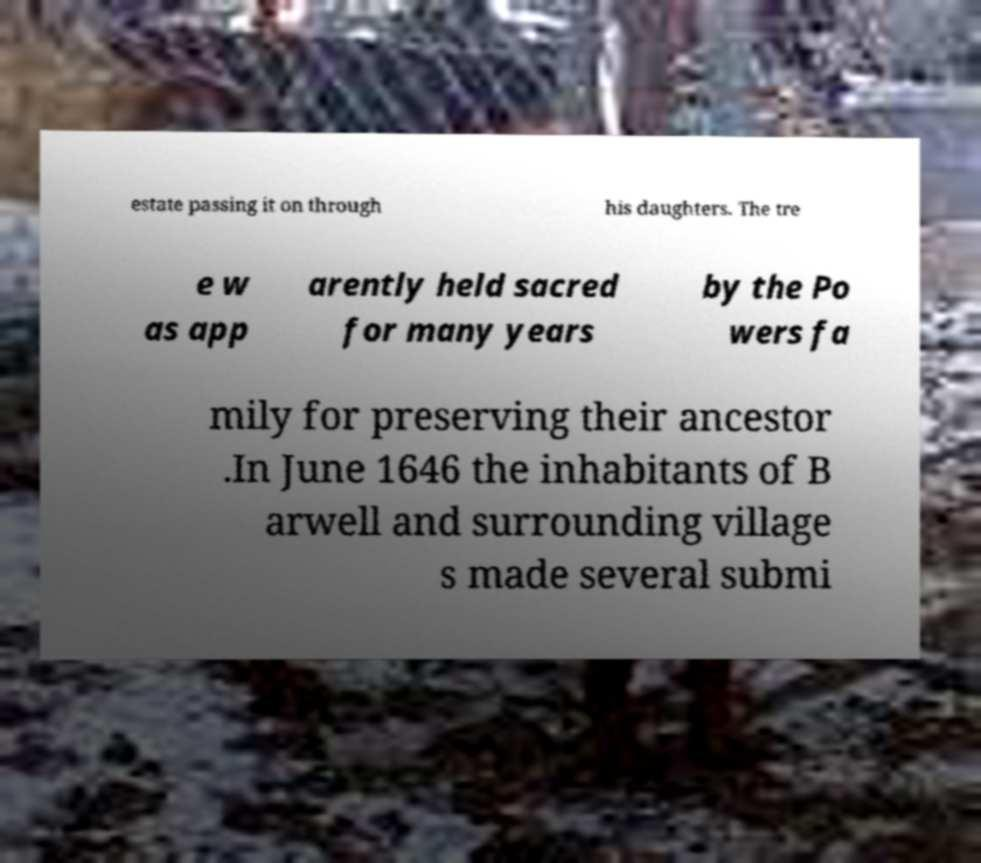I need the written content from this picture converted into text. Can you do that? estate passing it on through his daughters. The tre e w as app arently held sacred for many years by the Po wers fa mily for preserving their ancestor .In June 1646 the inhabitants of B arwell and surrounding village s made several submi 